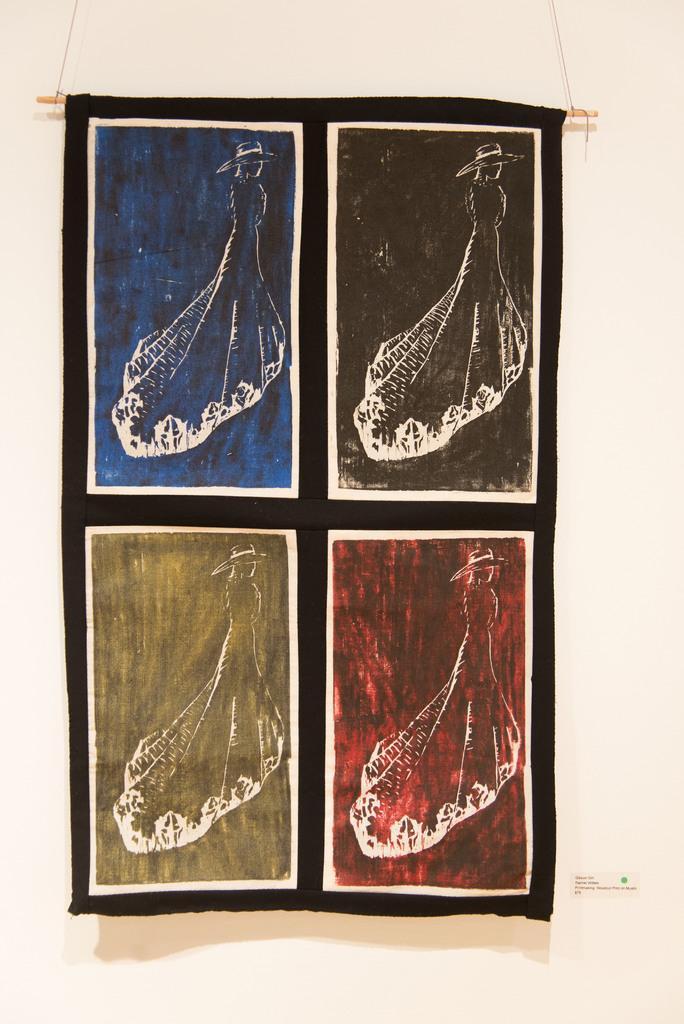Please provide a concise description of this image. In this image in the center there is one cloth, on the cloth there is some art and in the background there is wall. 